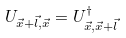<formula> <loc_0><loc_0><loc_500><loc_500>U _ { \vec { x } + \vec { l } , \vec { x } } = U _ { \vec { x } , \vec { x } + \vec { l } } ^ { \dagger }</formula> 